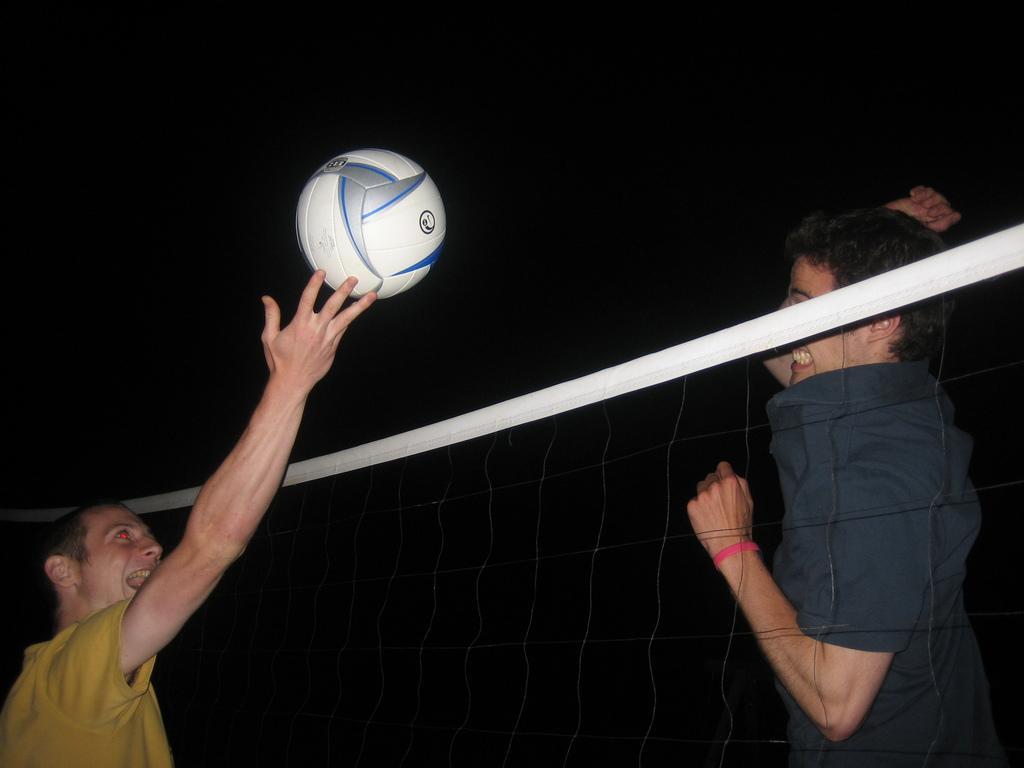Could you give a brief overview of what you see in this image? In the image there are two persons playing valley ball, there is a net in between them and the picture is captured in the night time. 